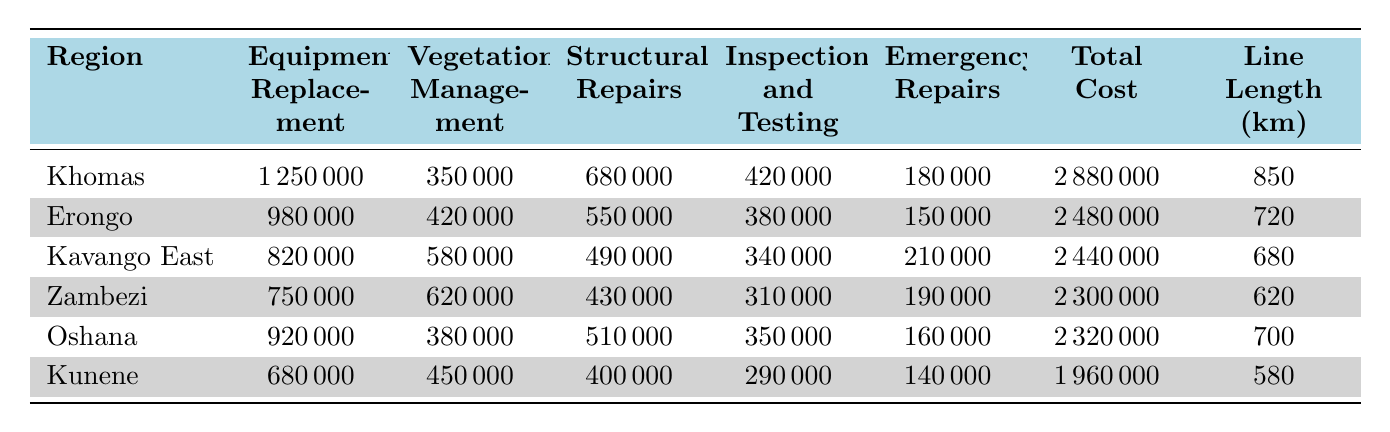What is the total maintenance cost for the Khomas region? The total maintenance cost for the Khomas region is explicitly listed in the table under 'Total Cost', which shows 2,880,000.
Answer: 2,880,000 Which region has the highest cost for Equipment Replacement? By comparing the values under 'Equipment Replacement', Khomas has the highest cost at 1,250,000, which is greater than the other regions' values.
Answer: Khomas What is the average total cost of maintenance across all regions? To find the average, first sum the total costs: 2,880,000 + 2,480,000 + 2,440,000 + 2,300,000 + 2,320,000 + 1,960,000 = 14,380,000. Then divide by the number of regions (6): 14,380,000 / 6 = 2,396,666.67.
Answer: 2,396,666.67 Which region has the lowest total maintenance cost? The 'Total Cost' values for each region show that Kunene has the lowest total cost of 1,960,000.
Answer: Kunene Is the total maintenance cost higher in Erongo than in Zambezi? Comparing the total costs, Erongo has 2,480,000 and Zambezi has 2,300,000. Since 2,480,000 is greater than 2,300,000, the statement is true.
Answer: Yes What is the sum of the costs for Vegetation Management for all regions? Adding the Vegetation Management costs: 350,000 (Khomas) + 420,000 (Erongo) + 580,000 (Kavango East) + 620,000 (Zambezi) + 380,000 (Oshana) + 450,000 (Kunene) equals a total of 2,800,000.
Answer: 2,800,000 How much more did Khomas spend on Structural Repairs compared to Kunene? The Structural Repairs cost for Khomas is 680,000, while for Kunene it is 400,000. Subtracting gives us 680,000 - 400,000 = 280,000.
Answer: 280,000 Which category of maintenance cost has the highest total across all regions? By adding up each category across the regions: Equipment Replacement = 4,150,000, Vegetation Management = 2,800,000, Structural Repairs = 3,350,000, Inspection and Testing = 2,370,000, Emergency Repairs = 1,430,000. The highest is Equipment Replacement, totaling 4,150,000.
Answer: Equipment Replacement If we consider only the cost of Emergency Repairs, which region spent the least? The Emergency Repairs costs for all regions are 180,000 (Khomas), 150,000 (Erongo), 210,000 (Kavango East), 190,000 (Zambezi), 160,000 (Oshana), and 140,000 (Kunene). The least amount spent is by Kunene at 140,000.
Answer: Kunene How does the line length in Khomas compare to that in Zambezi? The line lengths are 850 km for Khomas and 620 km for Zambezi. Since 850 km is longer than 620 km, Khomas has a longer line length.
Answer: Khomas has a longer line length 